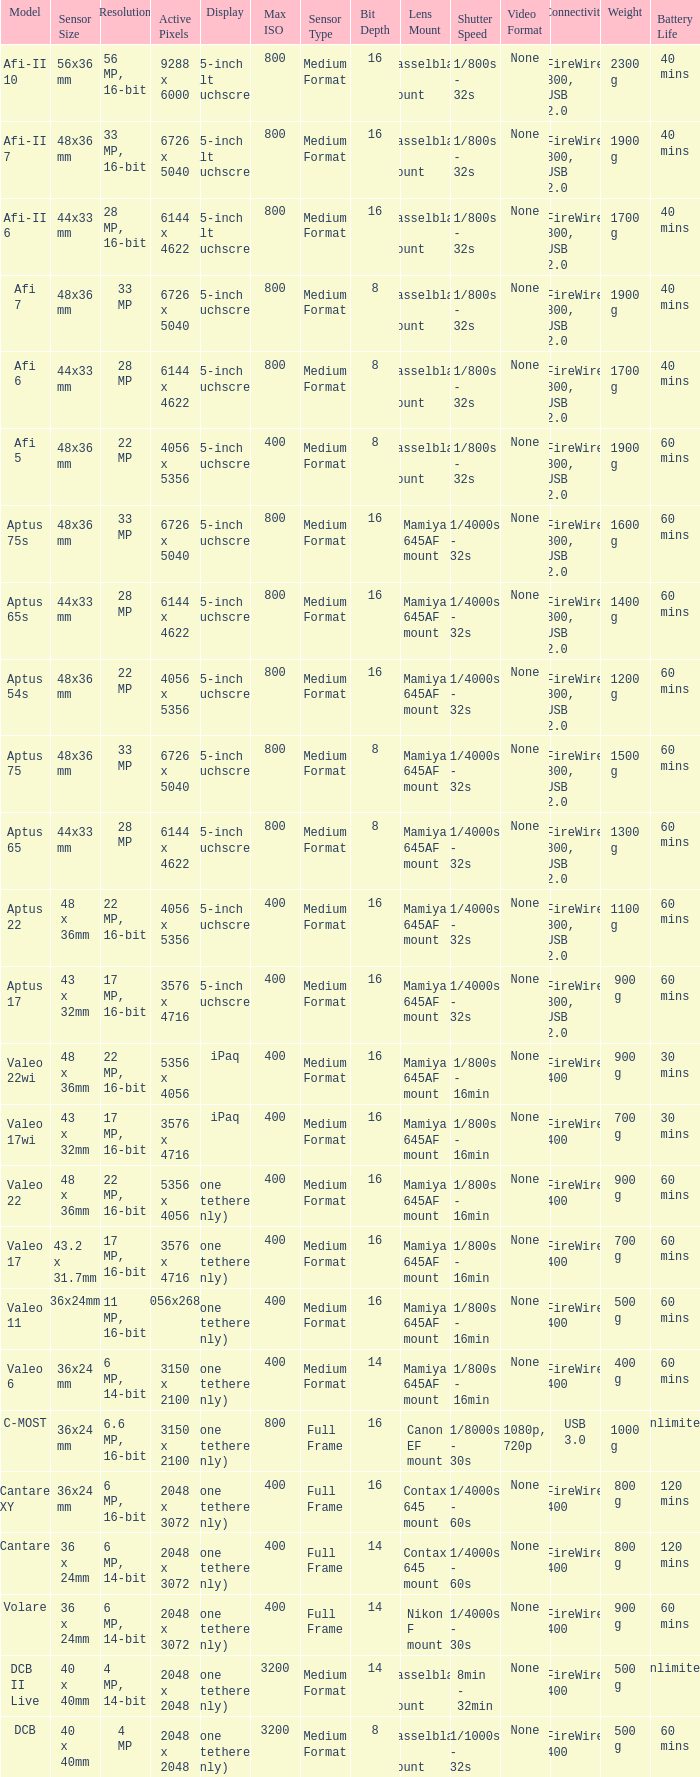What is the resolution of the camera that has 6726 x 5040 pixels and a model of afi 7? 33 MP. 